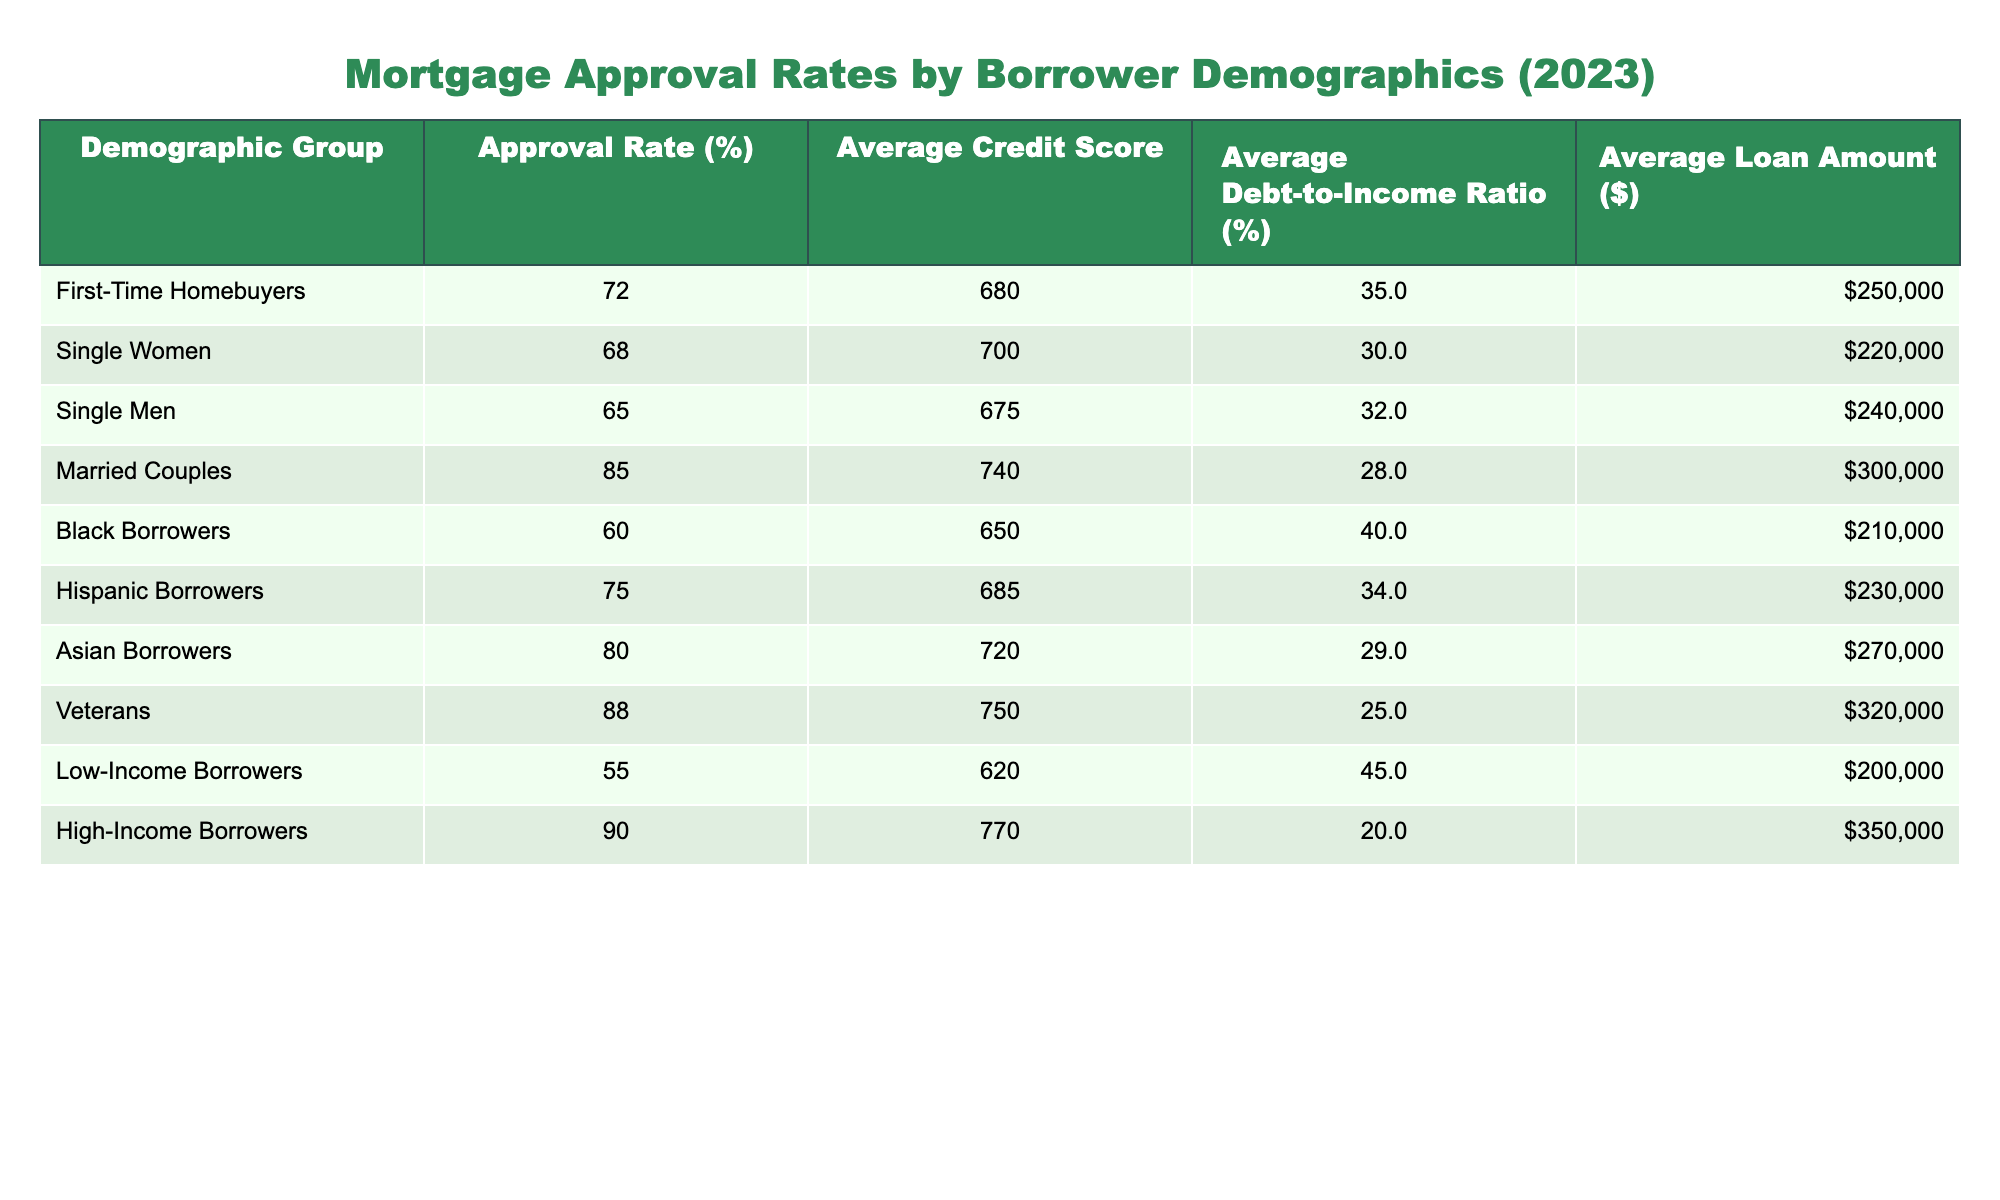What is the approval rate for Veterans? The table shows the demographic group "Veterans" with an approval rate listed under that category. Looking at the specific entry, the approval rate for Veterans is 88%.
Answer: 88% Which demographic group has the highest average credit score? By checking the average credit scores for each demographic group in the table, the scores are as follows: First-Time Homebuyers (680), Single Women (700), Single Men (675), Married Couples (740), Black Borrowers (650), Hispanic Borrowers (685), Asian Borrowers (720), Veterans (750), Low-Income Borrowers (620), and High-Income Borrowers (770). The highest average credit score is found in the High-Income Borrowers group at 770.
Answer: 770 Is the approval rate for Black Borrowers higher than for Single Men? Comparing the approval rates between Black Borrowers (60%) and Single Men (65%) in the table indicates that Black Borrowers have a lower approval rate. Therefore, the statement is false.
Answer: No What is the average loan amount for Married Couples? The average loan amount for the demographic group "Married Couples" can be found directly in the table, which shows the average loan amount as $300,000.
Answer: $300,000 If you look at Low-Income Borrowers and Veterans, which group has a better debt-to-income ratio? The debt-to-income ratio for Low-Income Borrowers is 45%, while for Veterans, it is 25%. Comparing these figures indicates that Veterans have a much better debt-to-income ratio. This is calculated simply by comparing the two numbers side by side.
Answer: Veterans have a better ratio What is the difference in approval rates between High-Income Borrowers and Single Women? To find the difference, we take the approval rate of High-Income Borrowers (90%) and subtract the approval rate of Single Women (68%). This gives us a difference of 90% - 68% = 22%. Thus, High-Income Borrowers have a 22% higher approval rate compared to Single Women.
Answer: 22% Is the average loan amount for Hispanic Borrowers higher than for Black Borrowers? Looking at the two groups, Hispanic Borrowers have an average loan amount of $230,000 and Black Borrowers have an average loan amount of $210,000. Since $230,000 is greater than $210,000, the statement is true.
Answer: Yes What is the average debt-to-income ratio across all groups? We can calculate the average debt-to-income ratio by summing the ratios and dividing by the number of demographic groups. The sums are 35 + 30 + 32 + 28 + 40 + 34 + 29 + 25 + 45 + 20 =  345. There are 10 groups, so the average is 345 / 10 = 34.5%.
Answer: 34.5% 